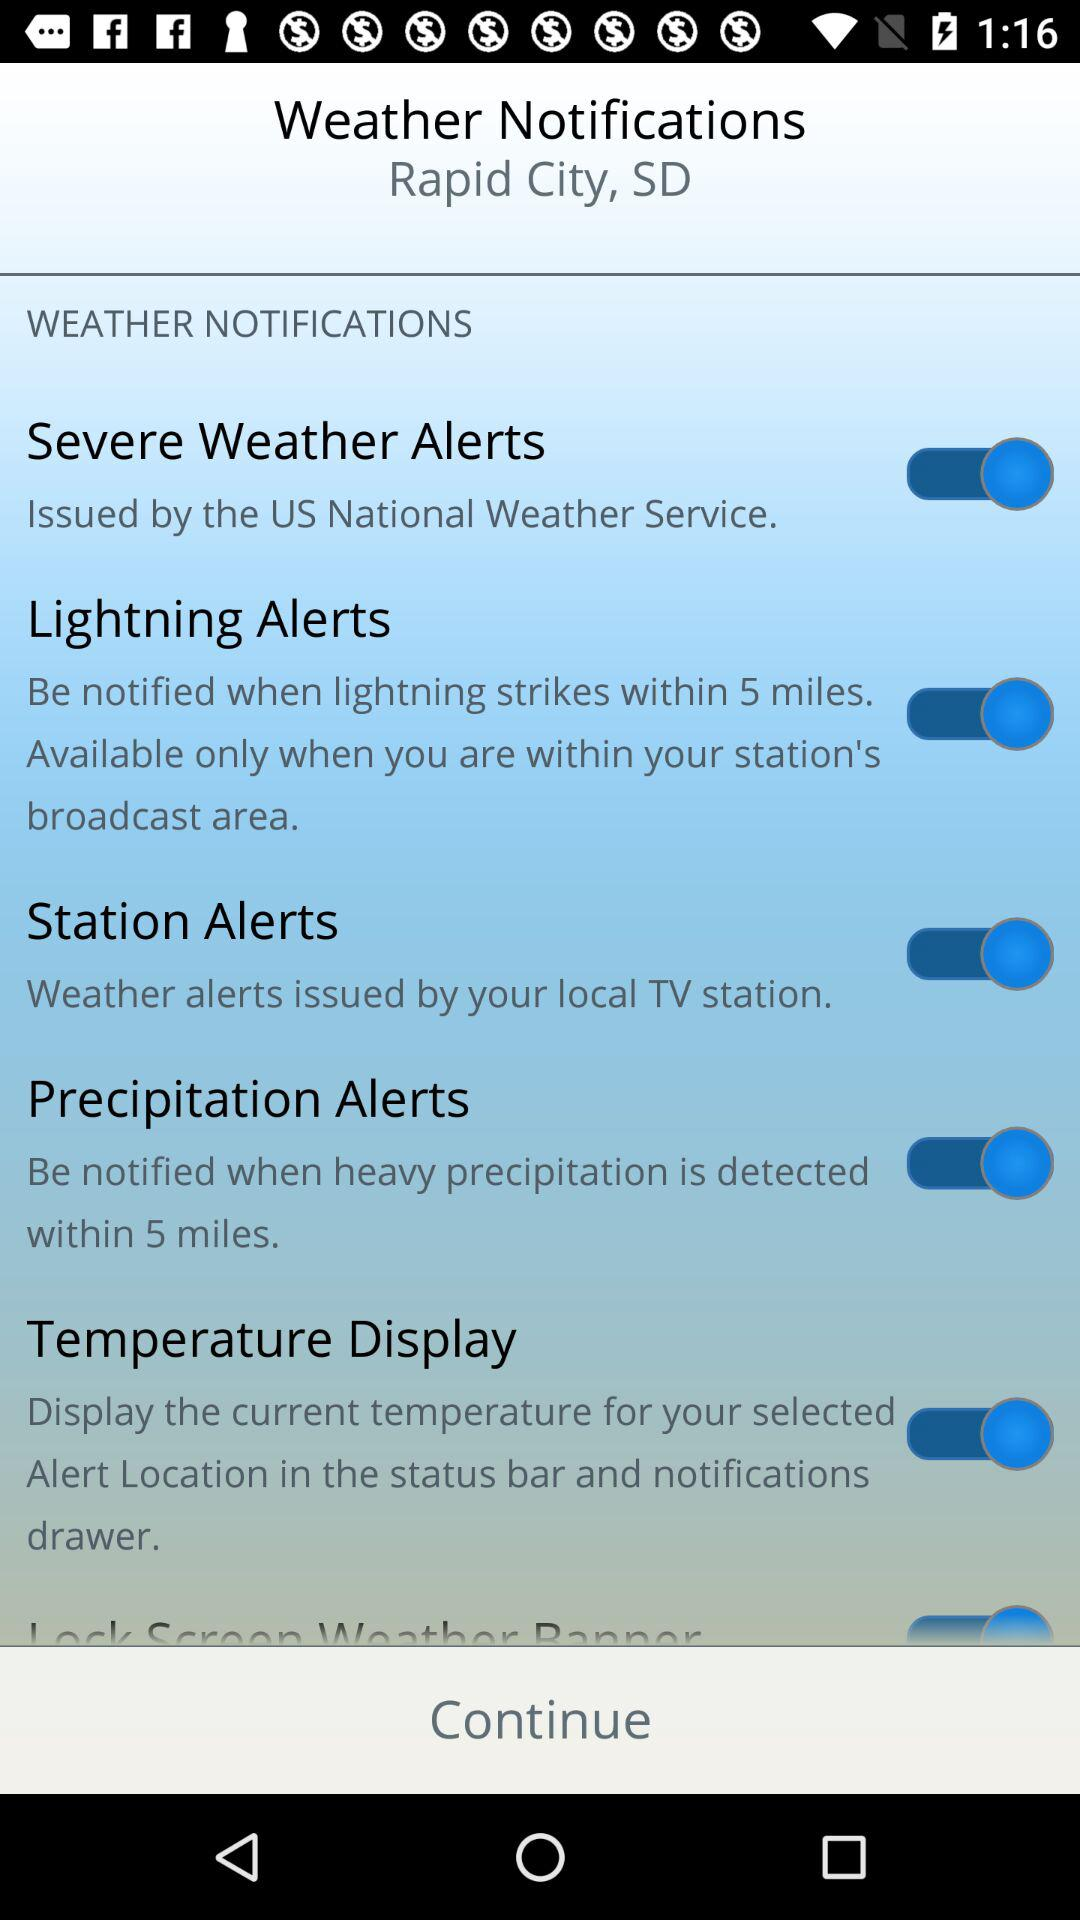Which alerts have been enabled? The alerts that have been enabled are "Severe Weather Alerts", "Lightning Alerts", "Station Alerts" and "Precipitation Alerts". 